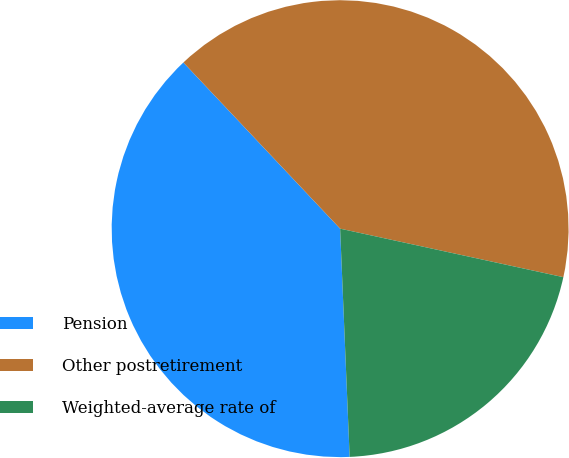<chart> <loc_0><loc_0><loc_500><loc_500><pie_chart><fcel>Pension<fcel>Other postretirement<fcel>Weighted-average rate of<nl><fcel>38.63%<fcel>40.44%<fcel>20.93%<nl></chart> 